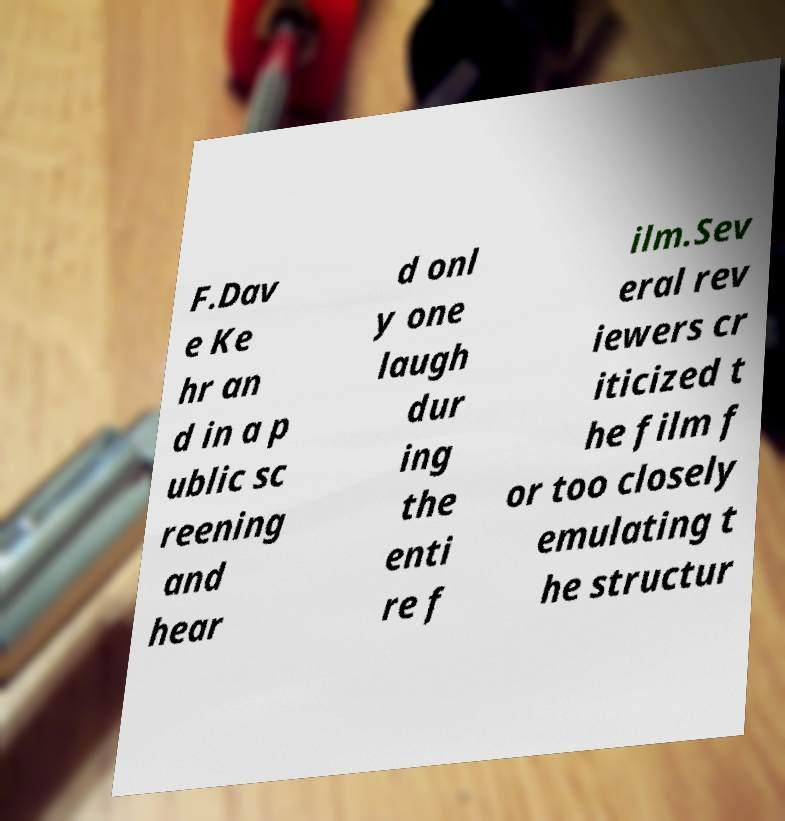For documentation purposes, I need the text within this image transcribed. Could you provide that? F.Dav e Ke hr an d in a p ublic sc reening and hear d onl y one laugh dur ing the enti re f ilm.Sev eral rev iewers cr iticized t he film f or too closely emulating t he structur 